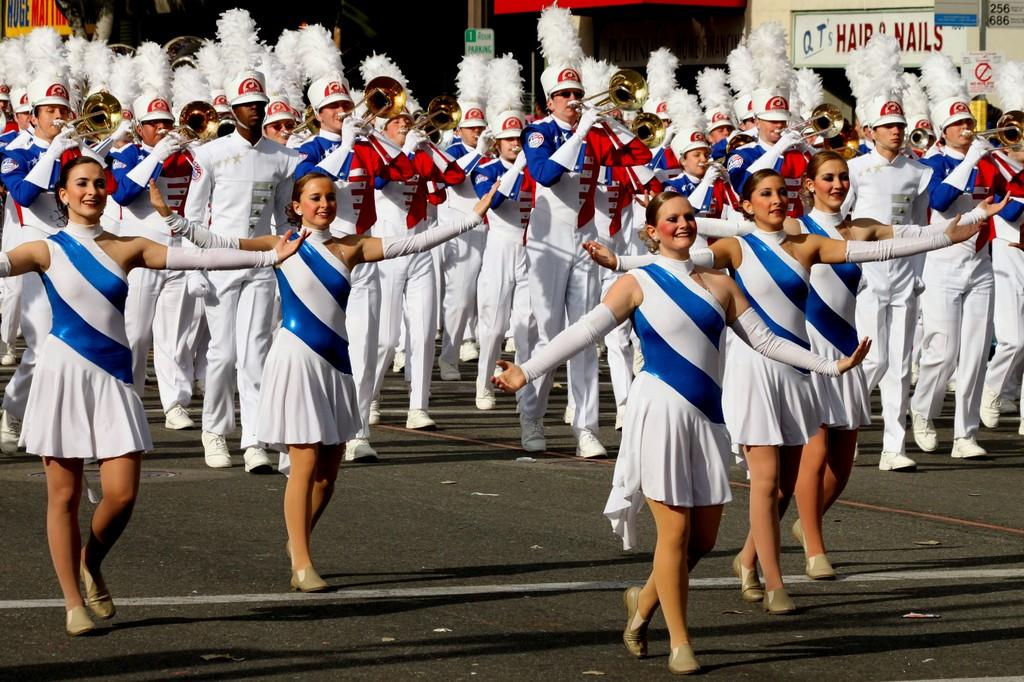<image>
Relay a brief, clear account of the picture shown. the parade passing a store called QT's Hair and Nails 